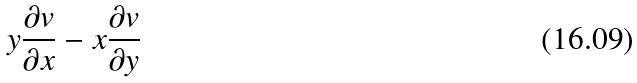<formula> <loc_0><loc_0><loc_500><loc_500>y \frac { \partial v } { \partial x } - x \frac { \partial v } { \partial y }</formula> 